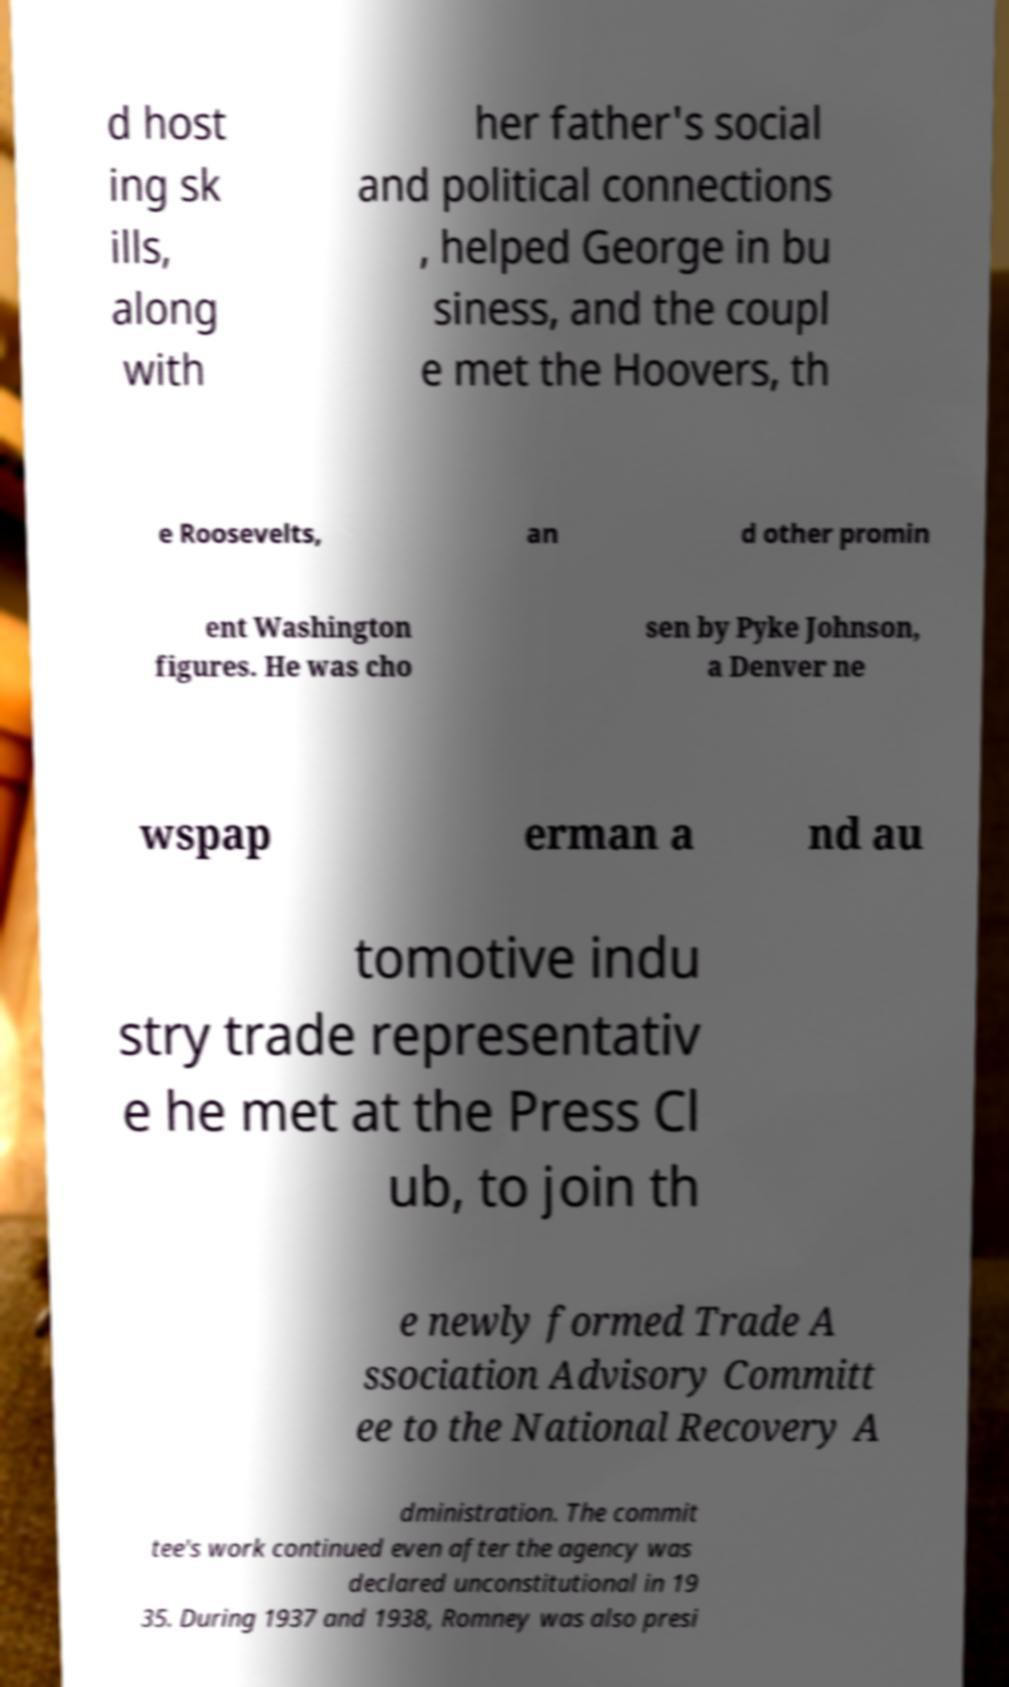For documentation purposes, I need the text within this image transcribed. Could you provide that? d host ing sk ills, along with her father's social and political connections , helped George in bu siness, and the coupl e met the Hoovers, th e Roosevelts, an d other promin ent Washington figures. He was cho sen by Pyke Johnson, a Denver ne wspap erman a nd au tomotive indu stry trade representativ e he met at the Press Cl ub, to join th e newly formed Trade A ssociation Advisory Committ ee to the National Recovery A dministration. The commit tee's work continued even after the agency was declared unconstitutional in 19 35. During 1937 and 1938, Romney was also presi 